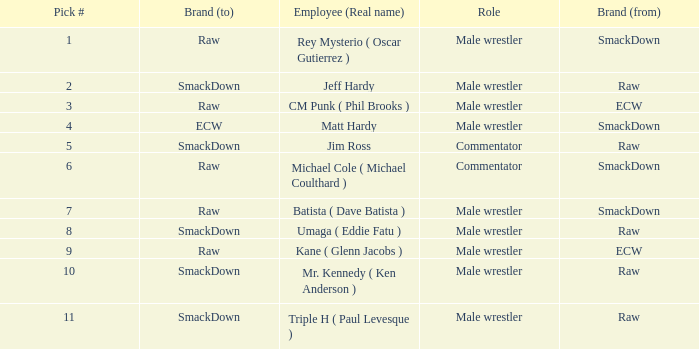What is the real name of the male wrestler from Raw with a pick # smaller than 6? Jeff Hardy. 